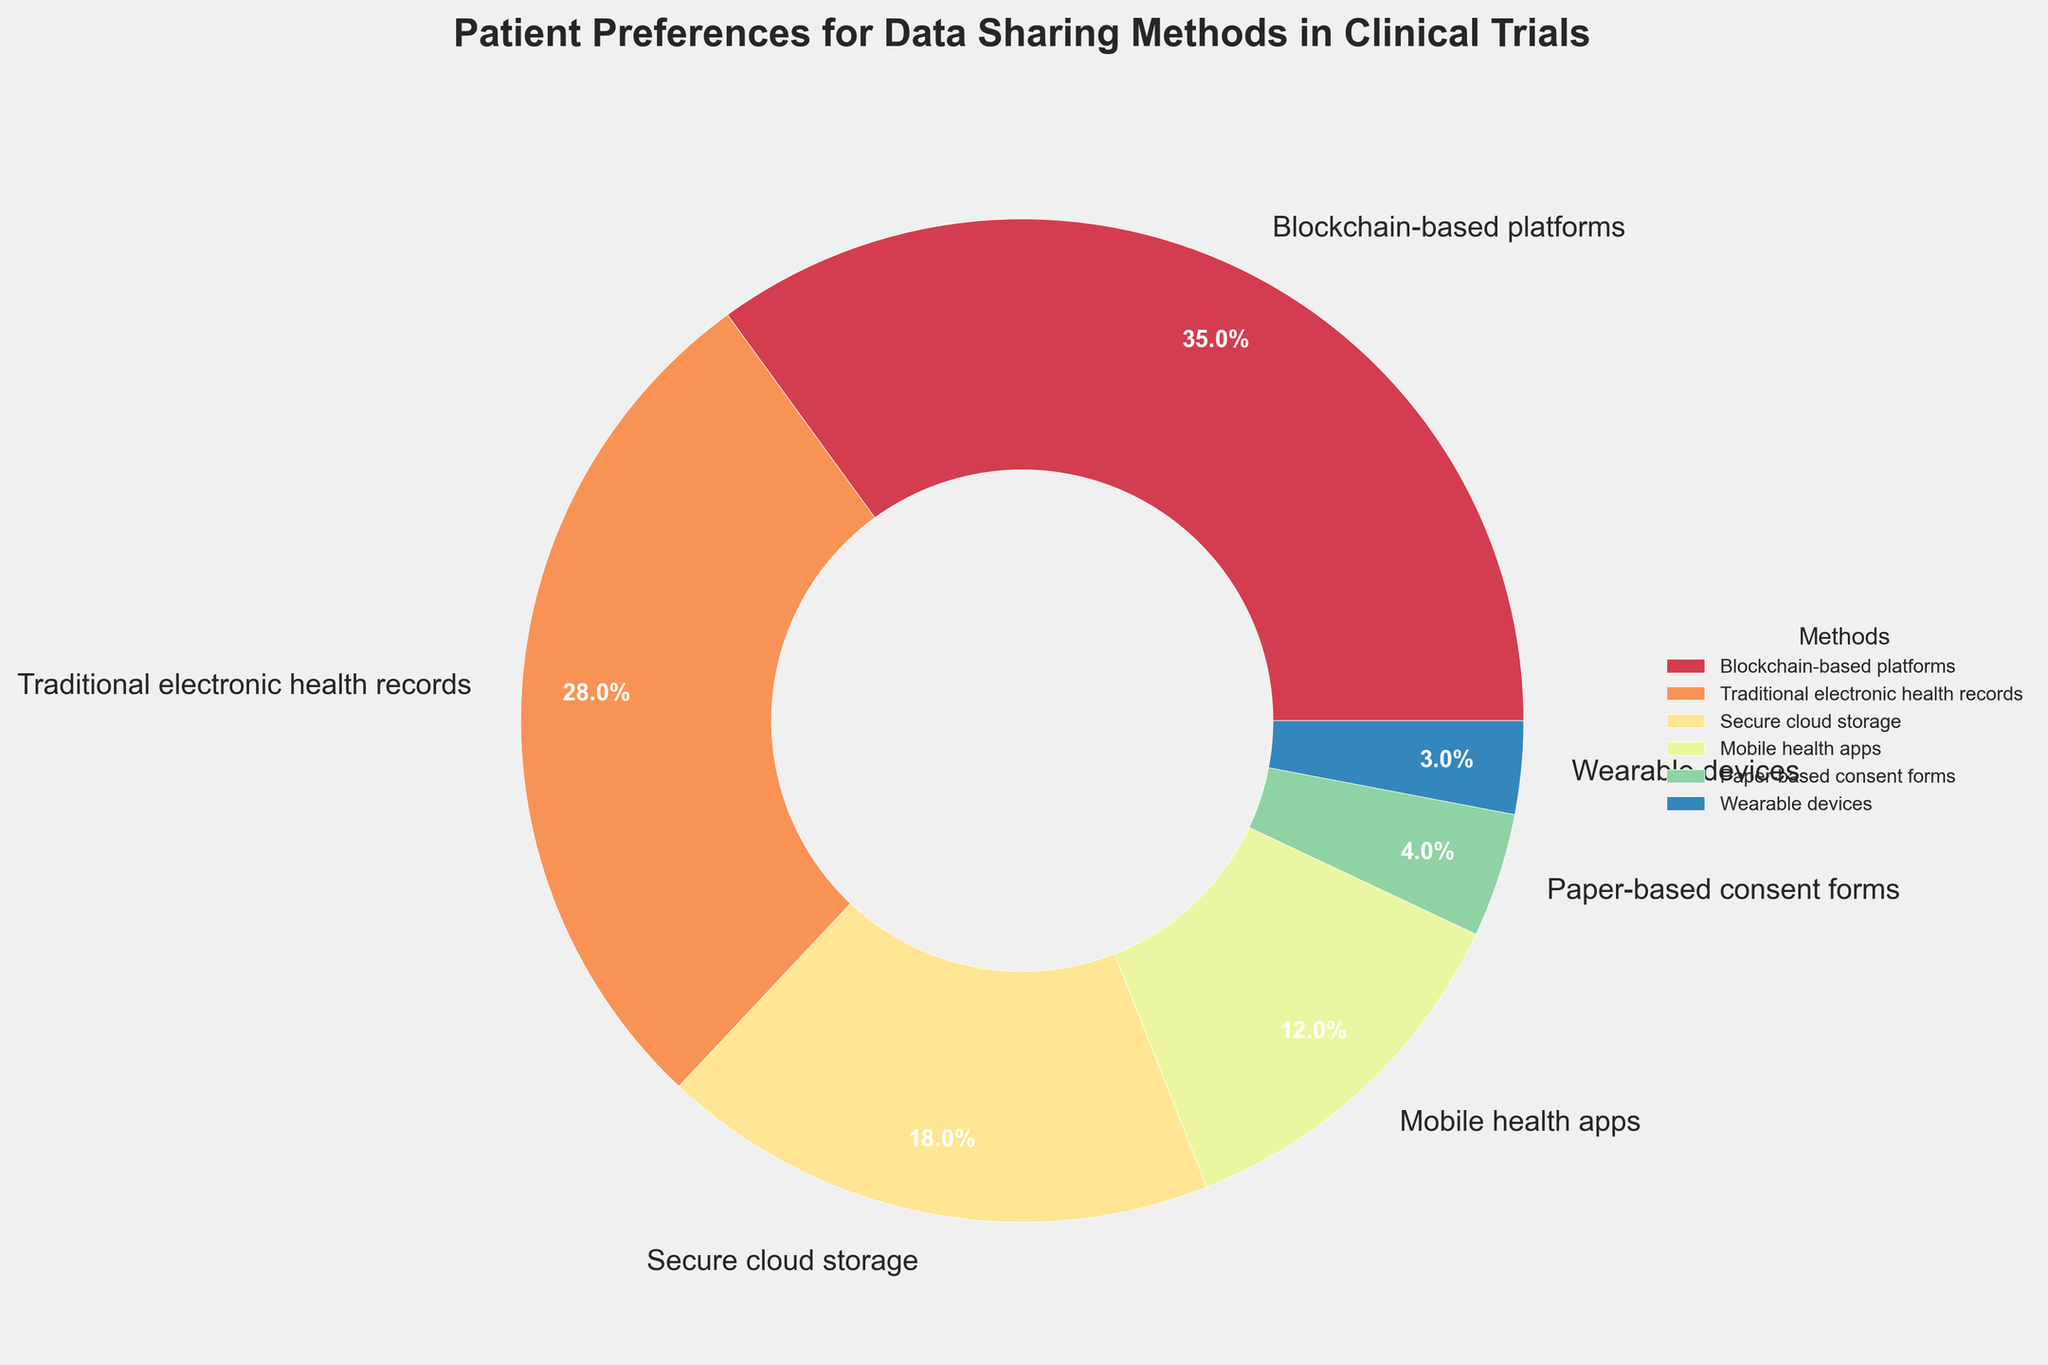What's the most preferred data sharing method among patients in clinical trials? According to the pie chart, the segment labeled "Blockchain-based platforms" occupies the largest portion. The percentage shown for this method is higher than any other methods.
Answer: Blockchain-based platforms What percentage of patients prefer traditional electronic health records for data sharing? The pie chart shows a segment labeled "Traditional electronic health records" with a percentage value. This value indicates the proportion of patients preferring this method.
Answer: 28% Which data sharing method is preferred by the least number of patients, and what is its percentage? The pie chart indicates that "Wearable devices" holds the smallest segment. The percentage in its segment shows the proportion of patients preferring this method.
Answer: Wearable devices, 3% Which two methods combined have a higher percentage than blockchain-based platforms? The pie chart shows that "Traditional electronic health records" and "Secure cloud storage" are the next two largest segments. Summing their percentages (28% + 18%) gives a value greater than the percentage of blockchain-based platforms (35%).
Answer: Traditional electronic health records and Secure cloud storage What is the combined percentage of patients preferring mobile health apps and paper-based consent forms? The segments for "Mobile health apps" and "Paper-based consent forms" have percentages labeled. Adding these values (12% and 4%) provides the combined percentage of patients preferring these methods.
Answer: 16% How much larger is the percentage of patients preferring blockchain-based platforms compared to those preferring secure cloud storage? The pie chart shows the percentages for blockchain-based platforms (35%) and secure cloud storage (18%). Subtracting the percentage of secure cloud storage from that of blockchain-based platforms (35% - 18%) gives the difference.
Answer: 17% What percentage of patients prefer methods other than mobile health apps? The percentage for patients preferring mobile health apps is 12%. Subtracting this percentage from the total (100%) gives the percentage for all other methods.
Answer: 88% What is the difference in preference percentage between the most and least preferred data sharing methods? The pie chart shows the percentages for blockchain-based platforms (most preferred, 35%) and wearable devices (least preferred, 3%). Subtracting these percentages (35% - 3%) provides the difference.
Answer: 32% Which method has a larger segment visually, secure cloud storage or mobile health apps, and by how much percentage? The pie chart shows the segments for secure cloud storage (18%) and mobile health apps (12%). The difference in their percentages (18% - 12%) indicates how much larger secure cloud storage is.
Answer: Secure cloud storage, 6% 